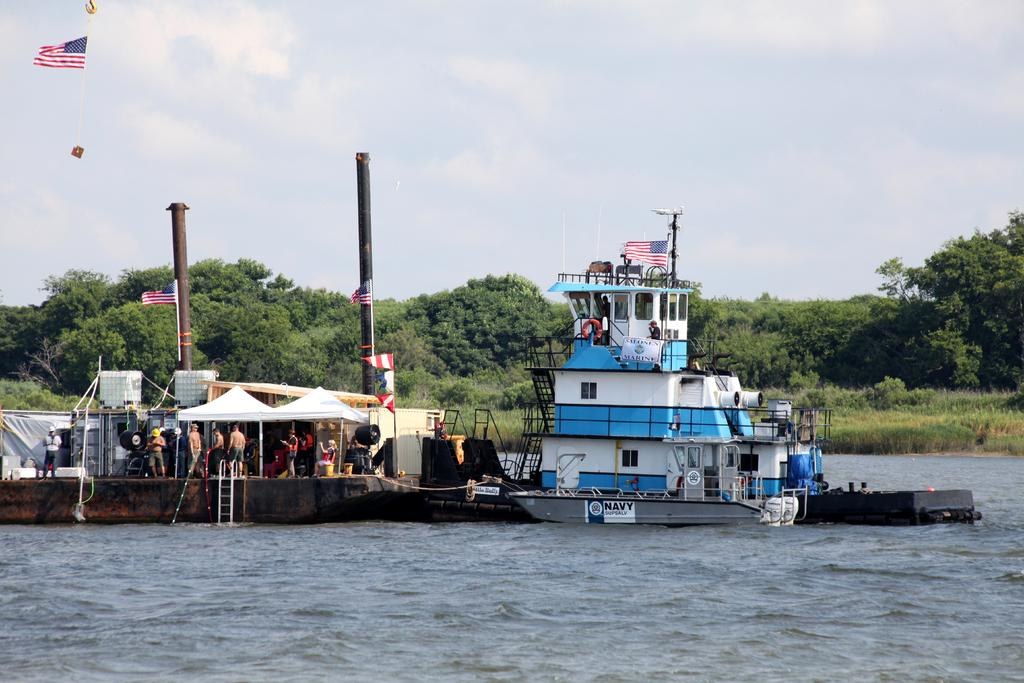What can be seen inside the ships in the image? There are people inside the ships in the image. What is visible in the background of the image? There are trees in the background of the image. What can be seen flying in the image? There are flags visible in the image. What is at the bottom of the image? There is water at the bottom of the image. What type of pen is being used by the people inside the ships in the image? There is no pen visible in the image, as it features ships with people inside and flags flying. 